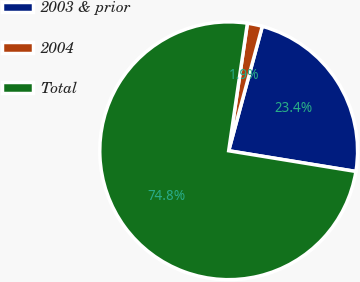Convert chart. <chart><loc_0><loc_0><loc_500><loc_500><pie_chart><fcel>2003 & prior<fcel>2004<fcel>Total<nl><fcel>23.37%<fcel>1.88%<fcel>74.76%<nl></chart> 